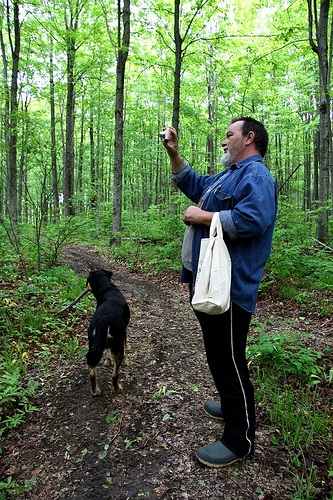<image>
Can you confirm if the person is in front of the trees? Yes. The person is positioned in front of the trees, appearing closer to the camera viewpoint. 